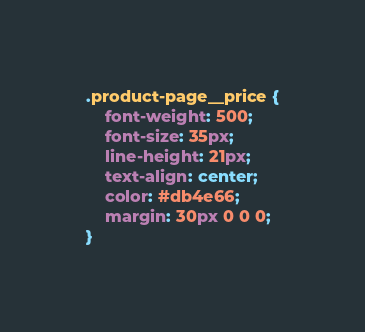<code> <loc_0><loc_0><loc_500><loc_500><_CSS_>.product-page__price {
    font-weight: 500;
    font-size: 35px;
    line-height: 21px;
    text-align: center;
    color: #db4e66;
    margin: 30px 0 0 0;
}
</code> 